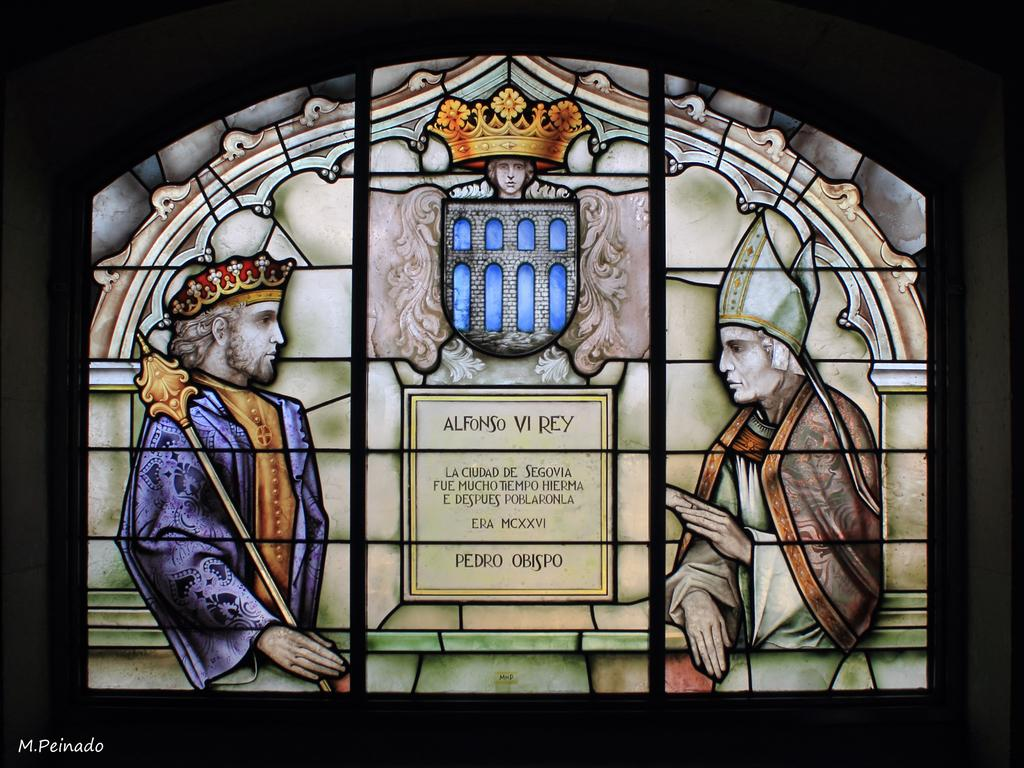<image>
Render a clear and concise summary of the photo. A stained glass painting with Alfonso VI Rey on it. 